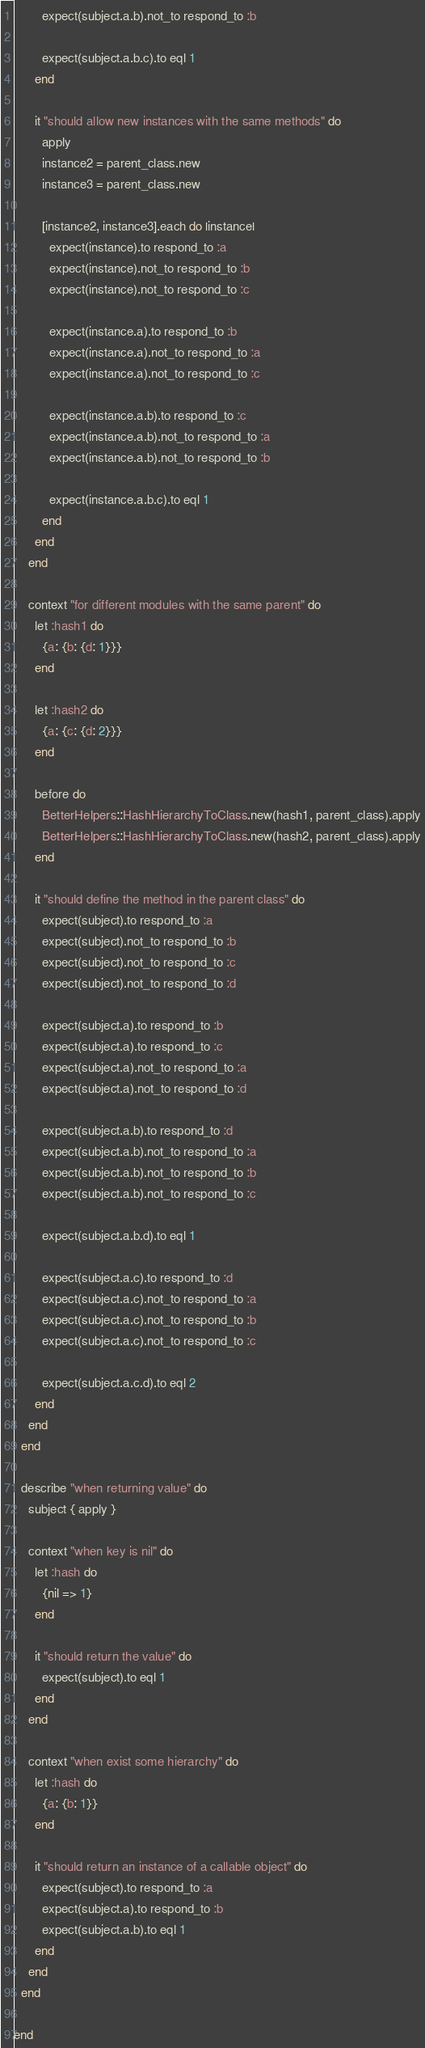Convert code to text. <code><loc_0><loc_0><loc_500><loc_500><_Ruby_>        expect(subject.a.b).not_to respond_to :b

        expect(subject.a.b.c).to eql 1
      end

      it "should allow new instances with the same methods" do
        apply
        instance2 = parent_class.new
        instance3 = parent_class.new

        [instance2, instance3].each do |instance|
          expect(instance).to respond_to :a
          expect(instance).not_to respond_to :b
          expect(instance).not_to respond_to :c

          expect(instance.a).to respond_to :b
          expect(instance.a).not_to respond_to :a
          expect(instance.a).not_to respond_to :c

          expect(instance.a.b).to respond_to :c
          expect(instance.a.b).not_to respond_to :a
          expect(instance.a.b).not_to respond_to :b

          expect(instance.a.b.c).to eql 1
        end
      end
    end

    context "for different modules with the same parent" do
      let :hash1 do
        {a: {b: {d: 1}}}
      end

      let :hash2 do
        {a: {c: {d: 2}}}
      end

      before do
        BetterHelpers::HashHierarchyToClass.new(hash1, parent_class).apply
        BetterHelpers::HashHierarchyToClass.new(hash2, parent_class).apply
      end

      it "should define the method in the parent class" do
        expect(subject).to respond_to :a
        expect(subject).not_to respond_to :b
        expect(subject).not_to respond_to :c
        expect(subject).not_to respond_to :d

        expect(subject.a).to respond_to :b
        expect(subject.a).to respond_to :c
        expect(subject.a).not_to respond_to :a
        expect(subject.a).not_to respond_to :d

        expect(subject.a.b).to respond_to :d
        expect(subject.a.b).not_to respond_to :a
        expect(subject.a.b).not_to respond_to :b
        expect(subject.a.b).not_to respond_to :c

        expect(subject.a.b.d).to eql 1

        expect(subject.a.c).to respond_to :d
        expect(subject.a.c).not_to respond_to :a
        expect(subject.a.c).not_to respond_to :b
        expect(subject.a.c).not_to respond_to :c

        expect(subject.a.c.d).to eql 2
      end
    end
  end

  describe "when returning value" do
    subject { apply }

    context "when key is nil" do
      let :hash do
        {nil => 1}
      end

      it "should return the value" do
        expect(subject).to eql 1
      end
    end

    context "when exist some hierarchy" do
      let :hash do
        {a: {b: 1}}
      end

      it "should return an instance of a callable object" do
        expect(subject).to respond_to :a
        expect(subject.a).to respond_to :b
        expect(subject.a.b).to eql 1
      end
    end
  end

end
</code> 